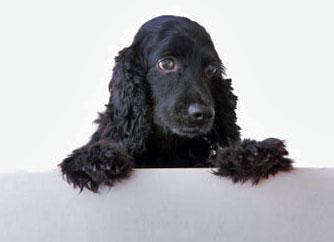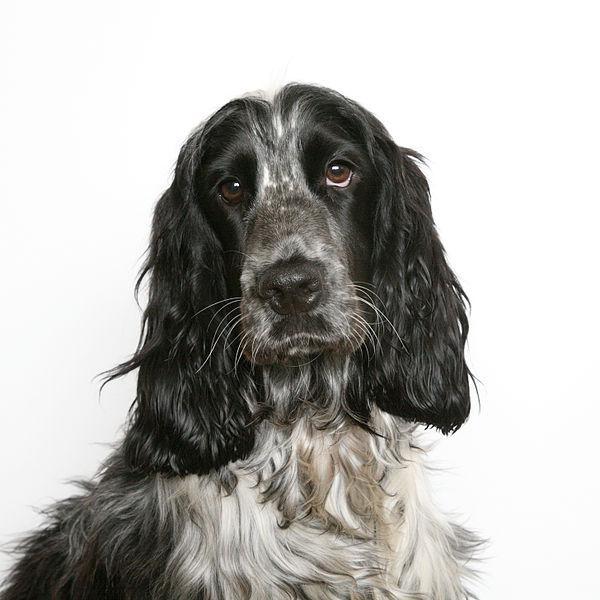The first image is the image on the left, the second image is the image on the right. Assess this claim about the two images: "There are no less than three dogs visible". Correct or not? Answer yes or no. No. The first image is the image on the left, the second image is the image on the right. For the images displayed, is the sentence "The image on the right shows more than two dogs." factually correct? Answer yes or no. No. 